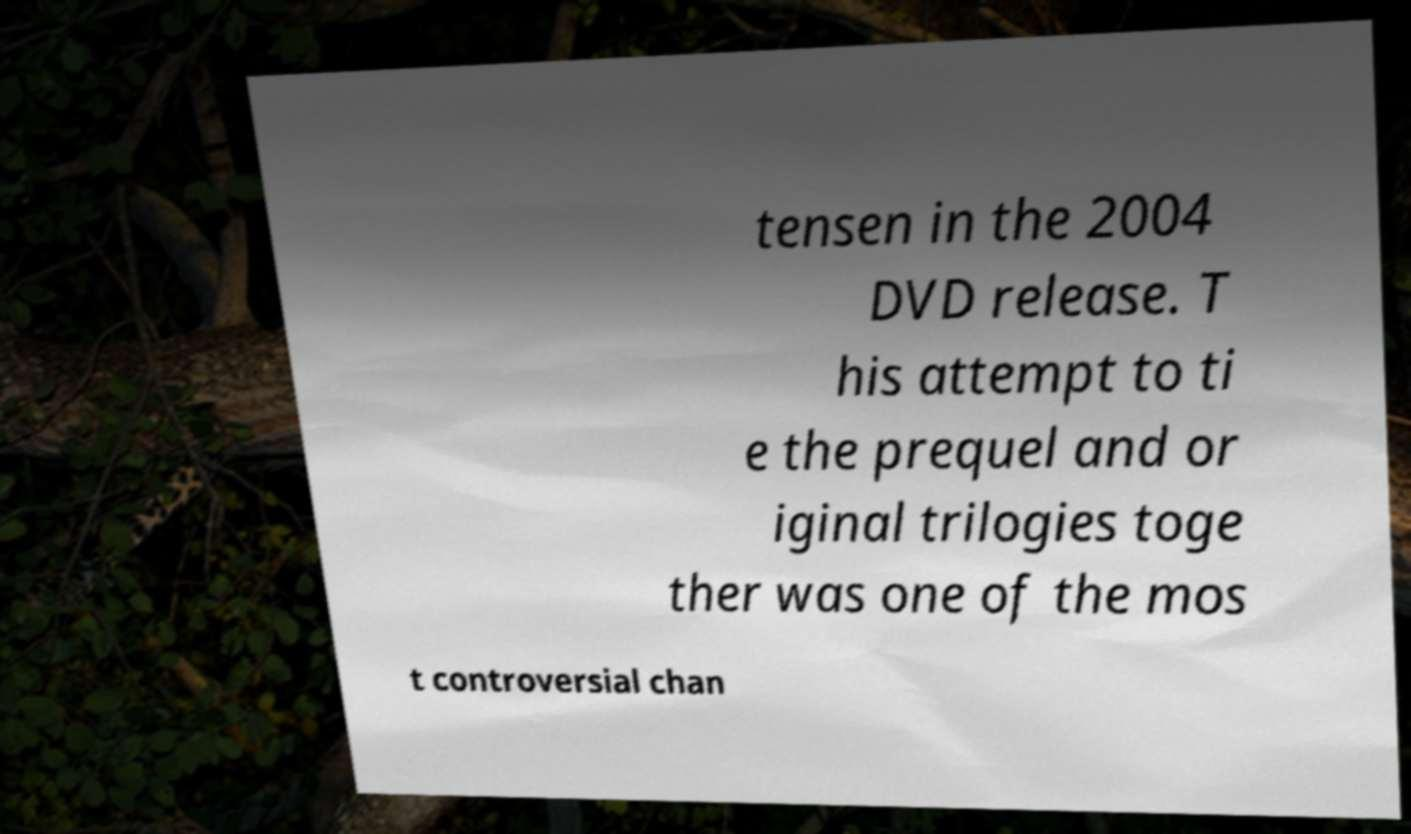There's text embedded in this image that I need extracted. Can you transcribe it verbatim? tensen in the 2004 DVD release. T his attempt to ti e the prequel and or iginal trilogies toge ther was one of the mos t controversial chan 